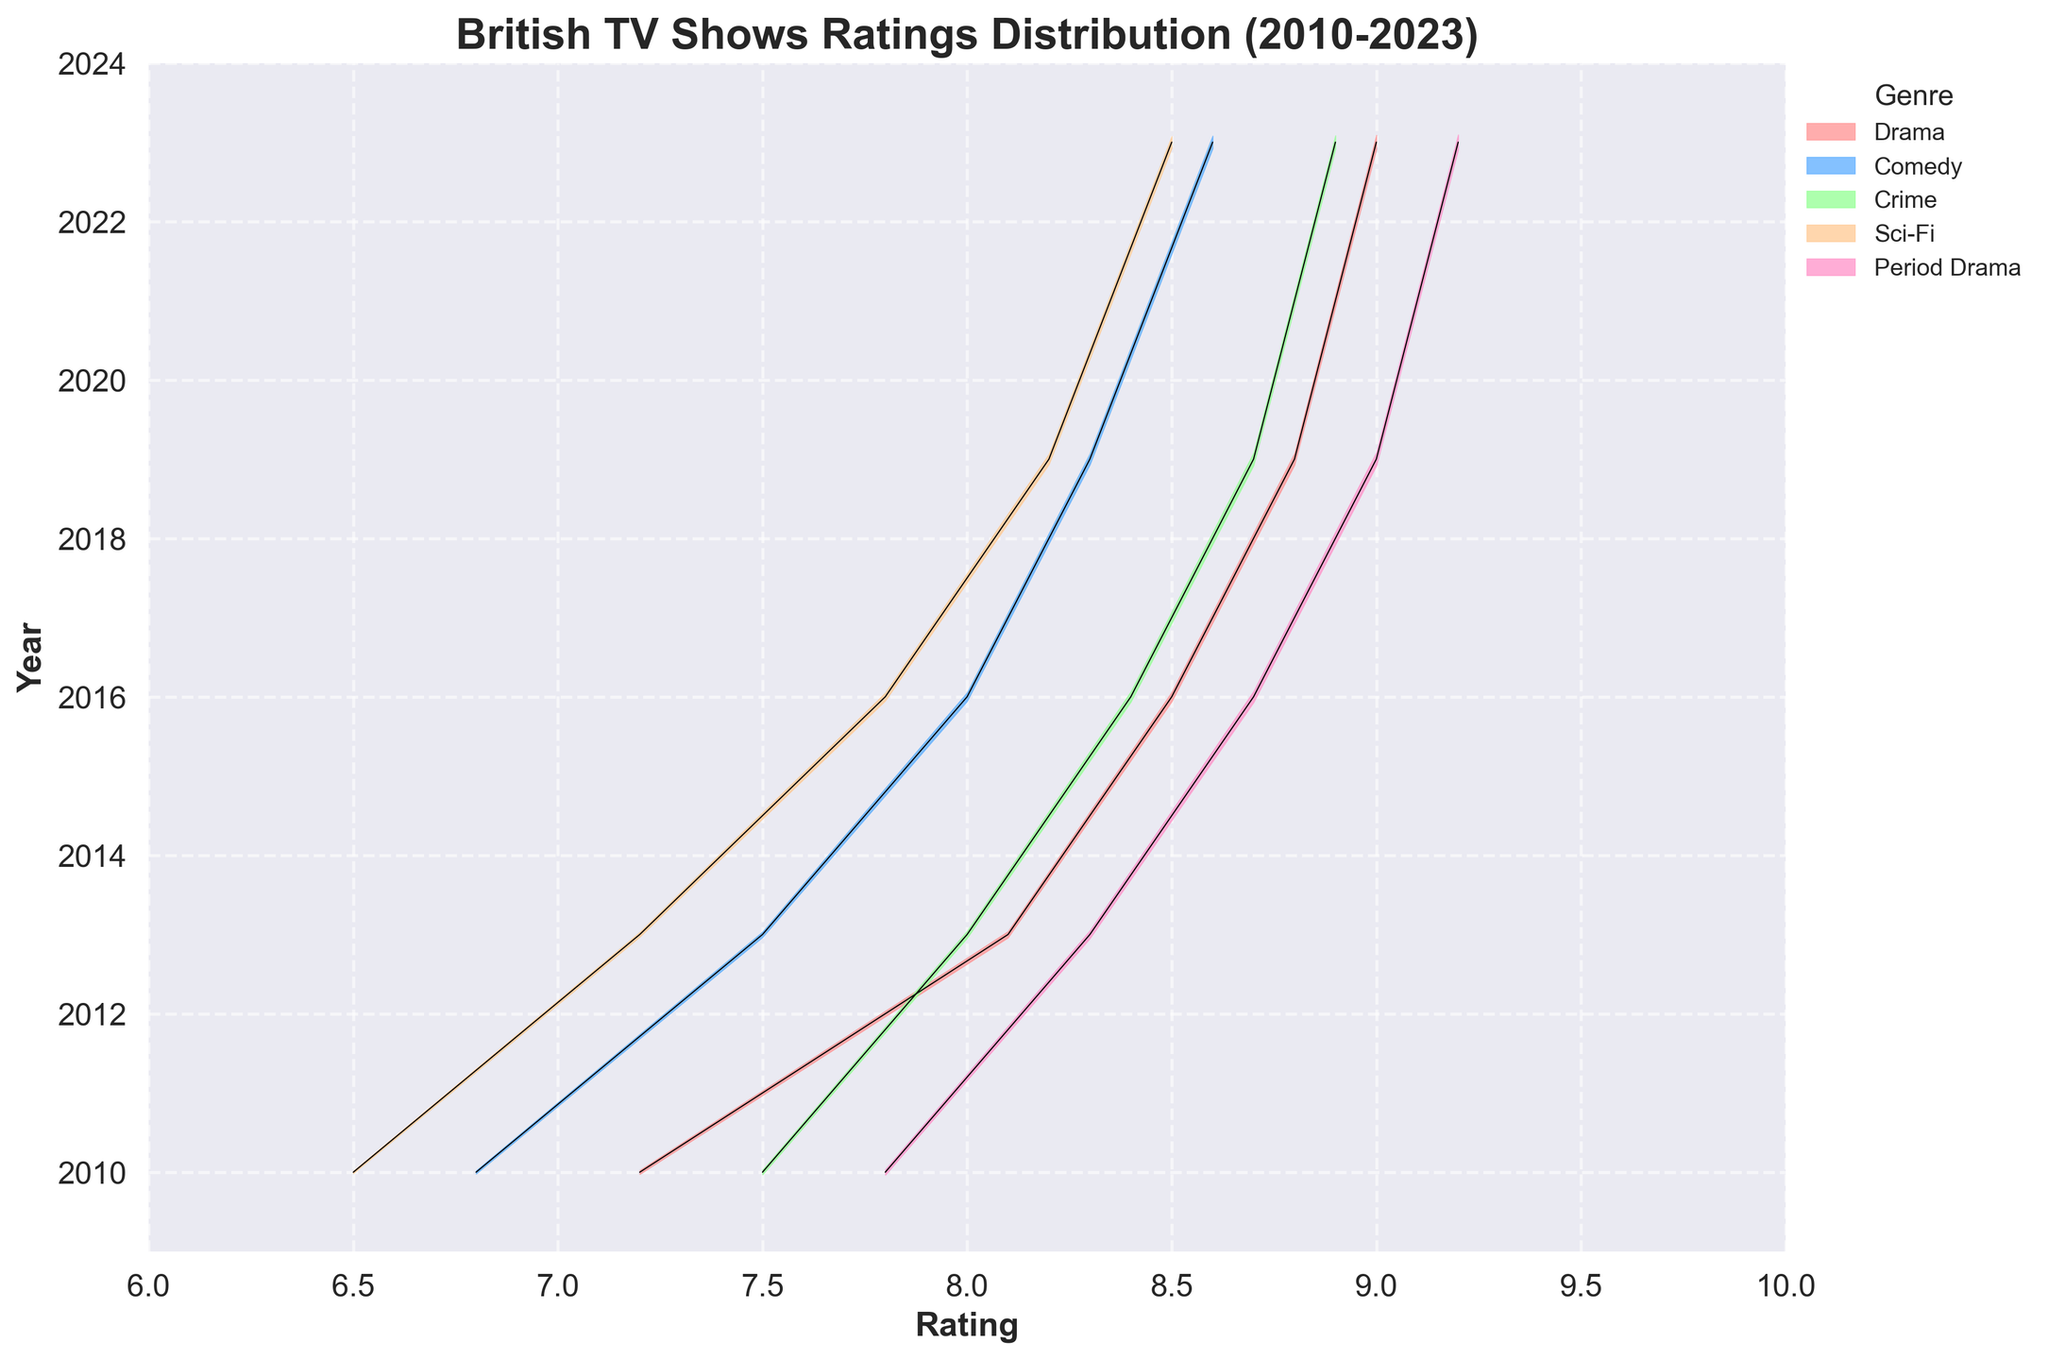What is the title of the plot? The title is displayed at the top of the plot. It provides a summary or main theme of the figure.
Answer: British TV Shows Ratings Distribution (2010-2023) Which genre has the highest density in 2023? Examine the ridgeline for each genre in the year 2023 and identify the one with the maximum density.
Answer: Period Drama What ratings range did Drama TV shows achieve in 2023? Look at the extent of the ridgeline for Drama in the year 2023 along the x-axis.
Answer: 9.0 How have ratings for Comedy TV shows changed from 2010 to 2023? Observe the position of the Comedy ridgeline from 2010 to 2023 and note any trends. Comedy ratings increase over the period.
Answer: Increased from 6.8 to 8.6 Which genre showed the most improvement in ratings from 2010 to 2023? Calculate the rating difference from 2010 to 2023 for each genre and then compare these values.
Answer: Period Drama (1.4 increase, from 7.8 to 9.2) How does the density distribution for Sci-Fi in 2023 compare to that of Drama in the same year? Look at both densities for Sci-Fi and Drama in 2023 and make a comparison.
Answer: Drama has a higher density What is the overall trend in ratings for Crime TV shows from 2010 to 2023? Follow the changes in the ridgeline for Crime across all years and describe the overall pattern.
Answer: The ratings increased steadily In what year did Drama achieve the highest density value? Identify the peak density value for Drama and note the corresponding year.
Answer: 2023 Which genre has the highest rating in 2016? Find the ridgeline position for all genres in 2016 and identify the highest rating.
Answer: Period Drama (8.7) How do the ratings of Sci-Fi TV shows in 2016 compare to those of Comedy in the same year? Compare the ridgeline positions for Sci-Fi and Comedy in 2016.
Answer: Sci-Fi (7.8) is lower than Comedy (8.0) 